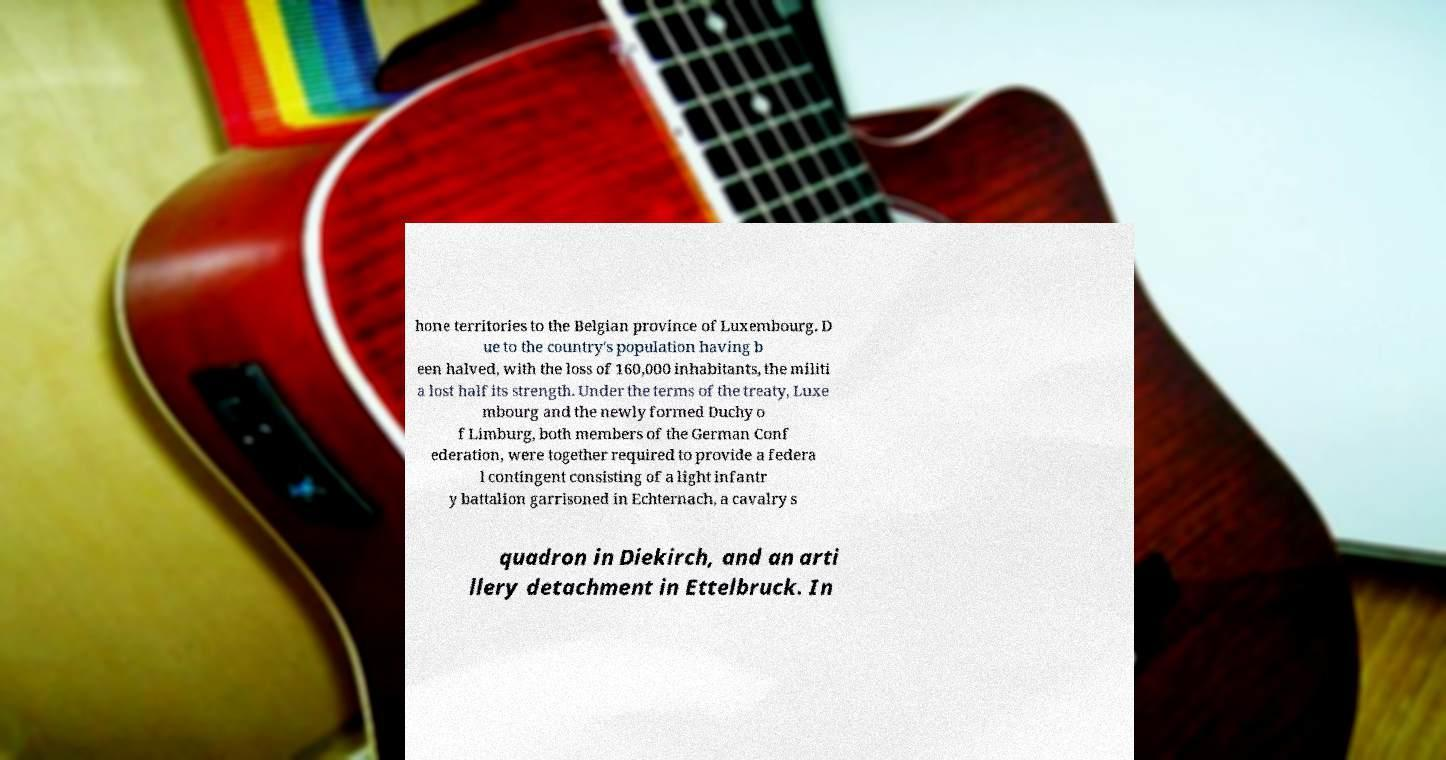There's text embedded in this image that I need extracted. Can you transcribe it verbatim? hone territories to the Belgian province of Luxembourg. D ue to the country's population having b een halved, with the loss of 160,000 inhabitants, the militi a lost half its strength. Under the terms of the treaty, Luxe mbourg and the newly formed Duchy o f Limburg, both members of the German Conf ederation, were together required to provide a federa l contingent consisting of a light infantr y battalion garrisoned in Echternach, a cavalry s quadron in Diekirch, and an arti llery detachment in Ettelbruck. In 